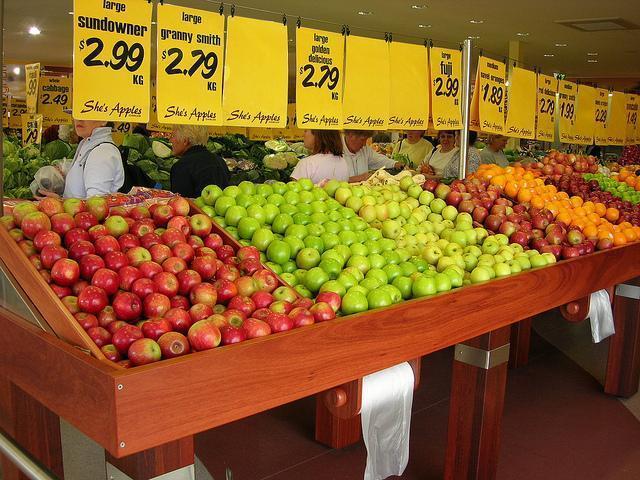How many different grapes are there?
Give a very brief answer. 0. How many red signs can be seen?
Give a very brief answer. 0. How many people are there?
Give a very brief answer. 3. How many apples are there?
Give a very brief answer. 2. 